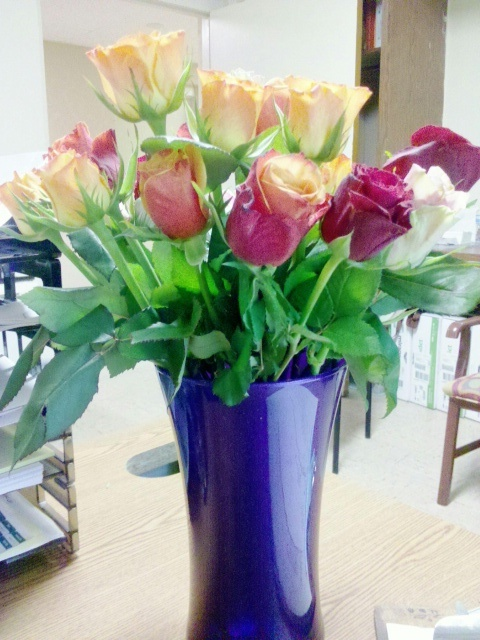Describe the objects in this image and their specific colors. I can see potted plant in lightgray, green, ivory, tan, and navy tones, vase in lightgray, navy, darkgray, and blue tones, and chair in lightgray, darkgray, and gray tones in this image. 